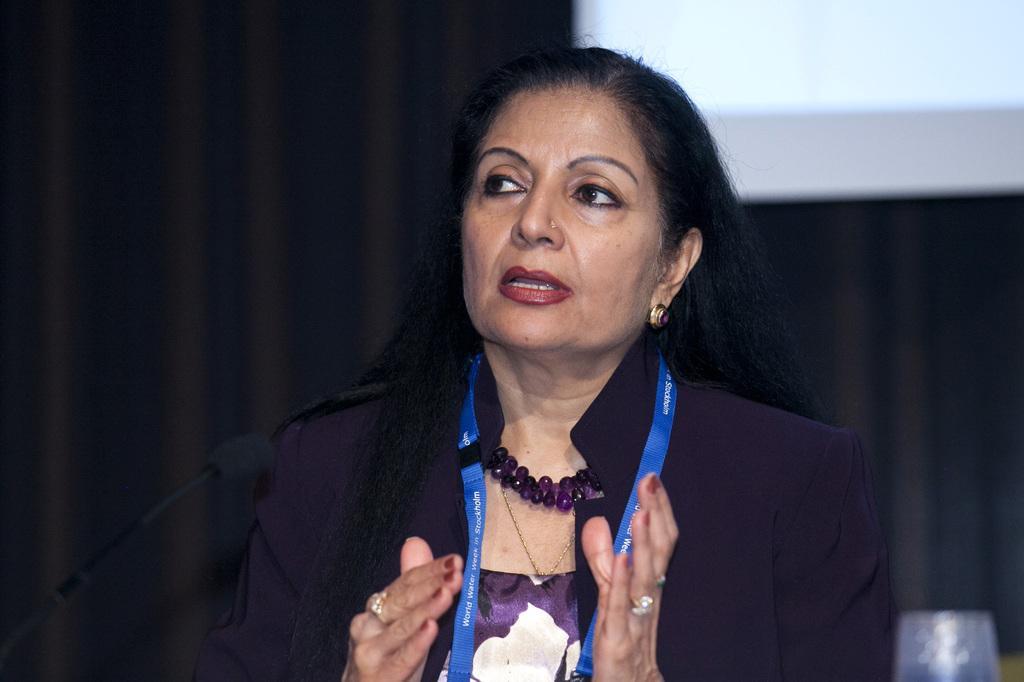Could you give a brief overview of what you see in this image? In this picture I can see a woman with a tag, there is a mike, and in the background it is looking like a projector screen. 